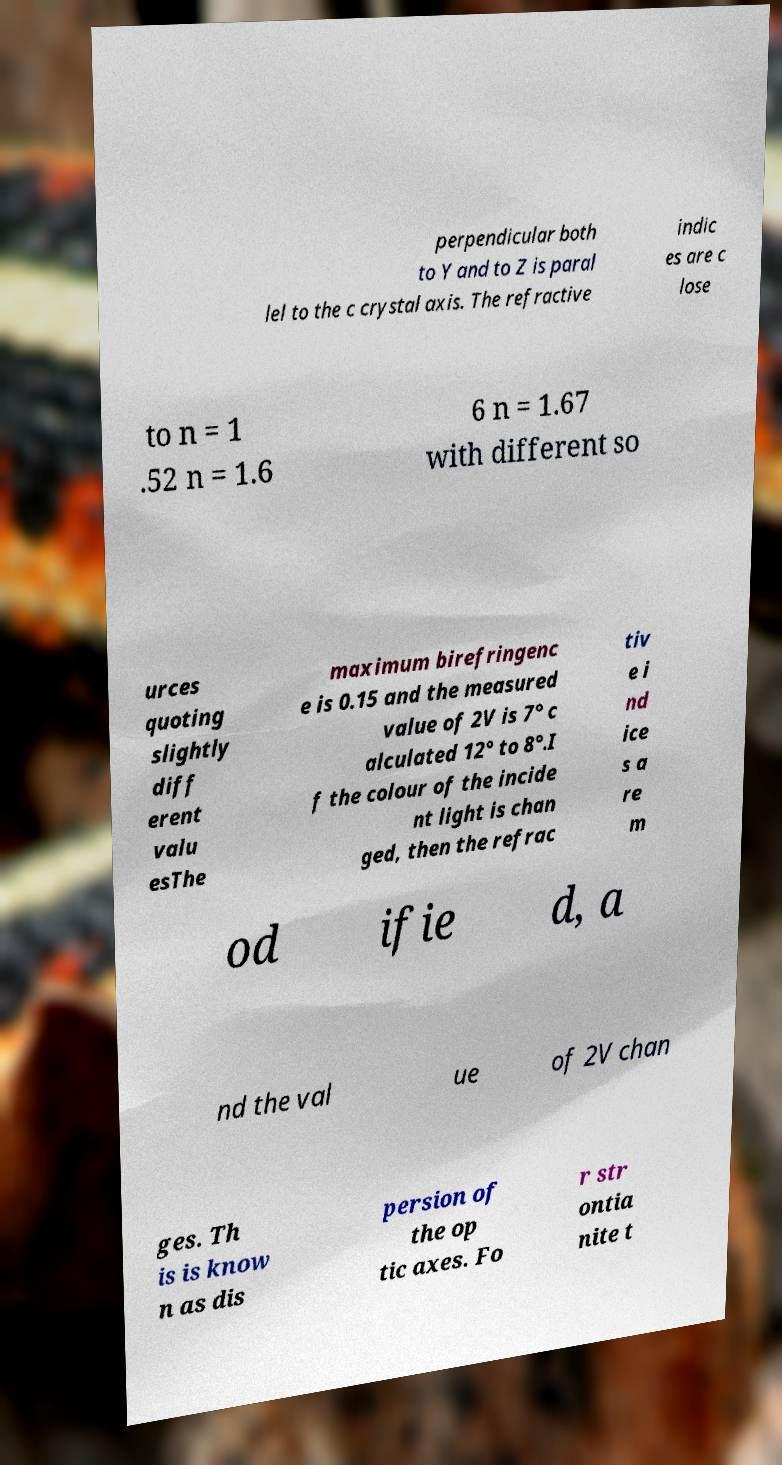Please identify and transcribe the text found in this image. perpendicular both to Y and to Z is paral lel to the c crystal axis. The refractive indic es are c lose to n = 1 .52 n = 1.6 6 n = 1.67 with different so urces quoting slightly diff erent valu esThe maximum birefringenc e is 0.15 and the measured value of 2V is 7° c alculated 12° to 8°.I f the colour of the incide nt light is chan ged, then the refrac tiv e i nd ice s a re m od ifie d, a nd the val ue of 2V chan ges. Th is is know n as dis persion of the op tic axes. Fo r str ontia nite t 